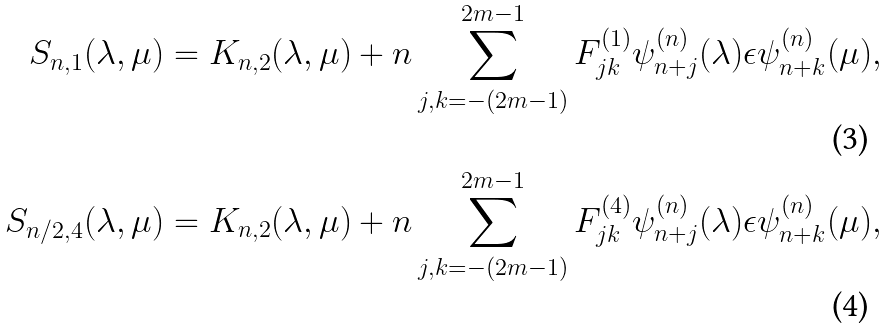<formula> <loc_0><loc_0><loc_500><loc_500>S _ { n , 1 } ( \lambda , \mu ) & = K _ { n , 2 } ( \lambda , \mu ) + n \sum _ { j , k = - ( 2 m - 1 ) } ^ { 2 m - 1 } F ^ { ( 1 ) } _ { j k } \psi _ { n + j } ^ { ( n ) } ( \lambda ) \epsilon \psi _ { n + k } ^ { ( n ) } ( \mu ) , \\ S _ { n / 2 , 4 } ( \lambda , \mu ) & = K _ { n , 2 } ( \lambda , \mu ) + n \sum _ { j , k = - ( 2 m - 1 ) } ^ { 2 m - 1 } F ^ { ( 4 ) } _ { j k } \psi _ { n + j } ^ { ( n ) } ( \lambda ) \epsilon \psi _ { n + k } ^ { ( n ) } ( \mu ) ,</formula> 